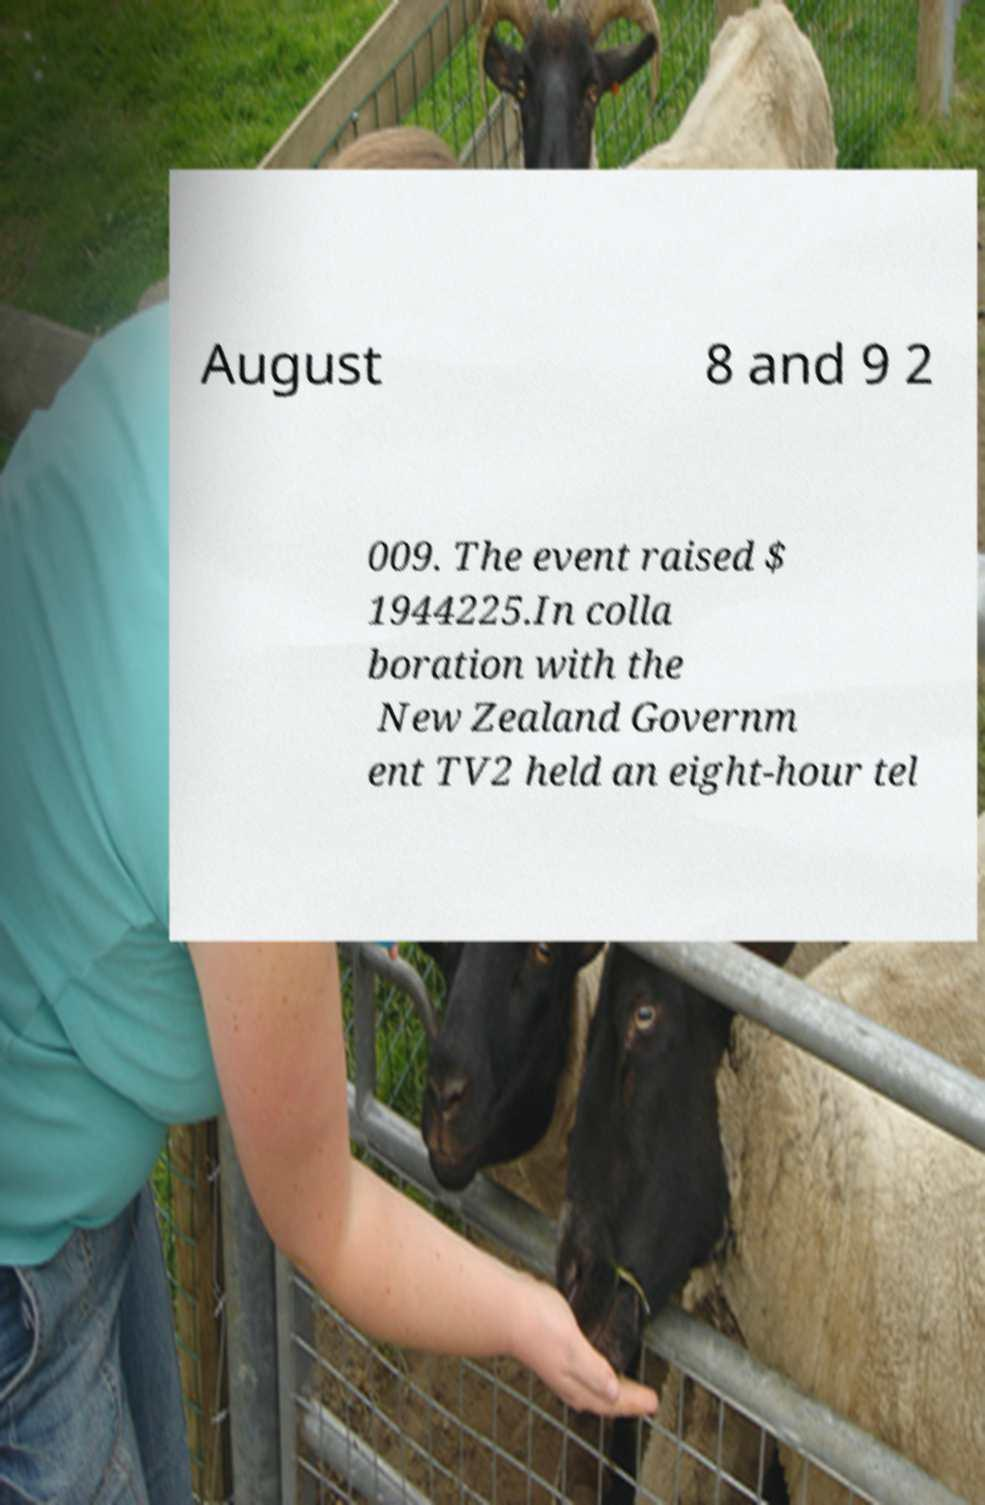Can you read and provide the text displayed in the image?This photo seems to have some interesting text. Can you extract and type it out for me? August 8 and 9 2 009. The event raised $ 1944225.In colla boration with the New Zealand Governm ent TV2 held an eight-hour tel 